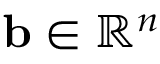Convert formula to latex. <formula><loc_0><loc_0><loc_500><loc_500>b \in \mathbb { R } ^ { n }</formula> 